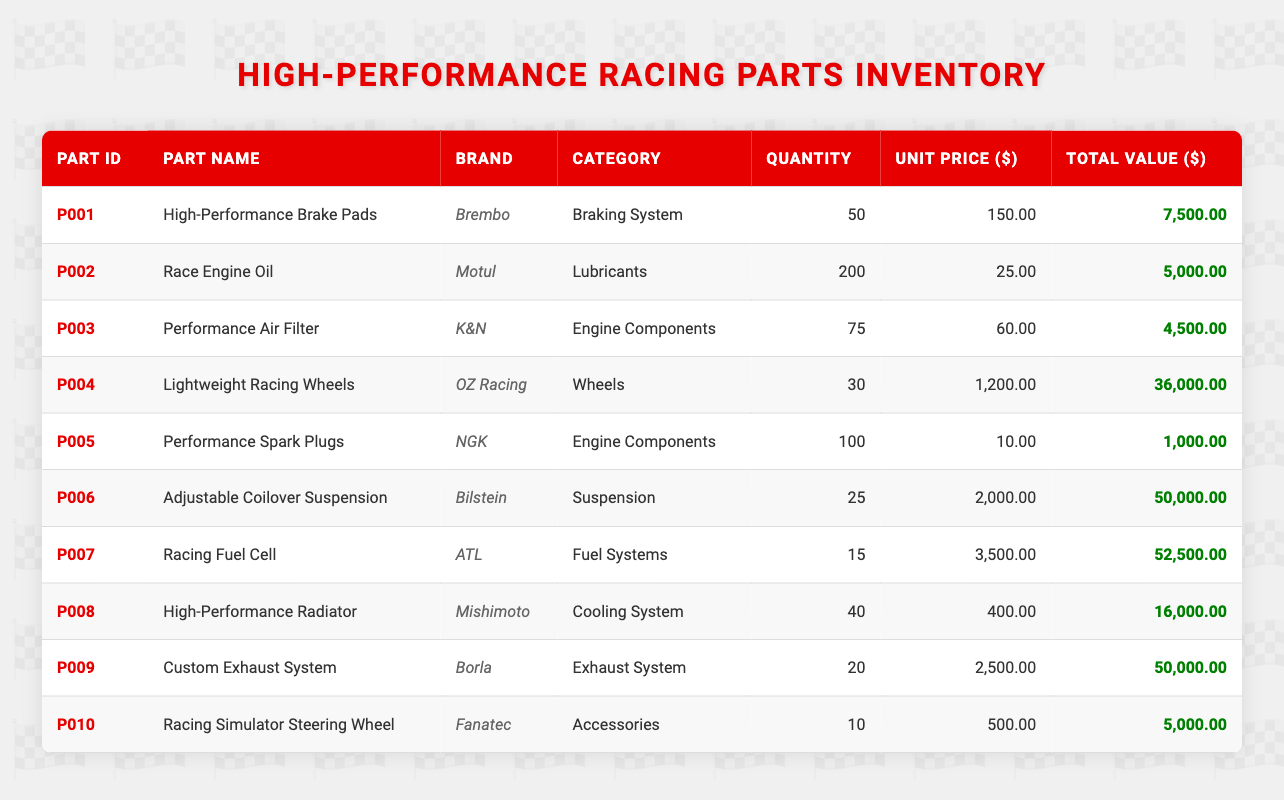What is the total quantity of "Engine Components" in the inventory? To find the total quantity of engine components, we must add the quantity of "Performance Air Filter" (75) and "Performance Spark Plugs" (100). Thus, 75 + 100 = 175.
Answer: 175 What is the total value of the "Braking System" category? The total value of the "Braking System" category consists of the High-Performance Brake Pads which has a total value of 7500.
Answer: 7500 Is there a part in the inventory with a unit price greater than 2000? The parts with a unit price are as follows: Adjustable Coilover Suspension (2000), Racing Fuel Cell (3500), and Custom Exhaust System (2500). Since there are some parts with a unit price greater than 2000, the statement is true.
Answer: Yes Which part has the highest total value? The total values of the parts are as follows: Adjustable Coilover Suspension (50000), Racing Fuel Cell (52500), and Custom Exhaust System (50000). The Racing Fuel Cell has the highest value at 52500.
Answer: Racing Fuel Cell What is the average unit price of parts in the "Accessories" category? The only part in the Accessories category is the Racing Simulator Steering Wheel with a unit price of 500. Since there is only one part, the average is 500.
Answer: 500 How many parts have a total value of more than 20000? The parts with total values above 20000 are Lightweight Racing Wheels (36000), Adjustable Coilover Suspension (50000), Racing Fuel Cell (52500), and Custom Exhaust System (50000). There are four parts that meet this criterion.
Answer: 4 Is the quantity of "Lubricants" higher than the quantity of "Cooling System"? The quantity of "Race Engine Oil" under Lubricants is 200 while the quantity of "High-Performance Radiator" under Cooling System is 40. Since 200 is greater than 40, the statement is true.
Answer: Yes What is the difference in total value between the part with the highest and lowest total value? The part with the highest total value is the Racing Fuel Cell at 52500, and the part with the lowest total value is the Performance Spark Plugs at 1000. Thus, the difference is 52500 - 1000 = 51500.
Answer: 51500 What category does the part "Custom Exhaust System" belong to? The part labeled "Custom Exhaust System" is categorized under "Exhaust System."
Answer: Exhaust System 